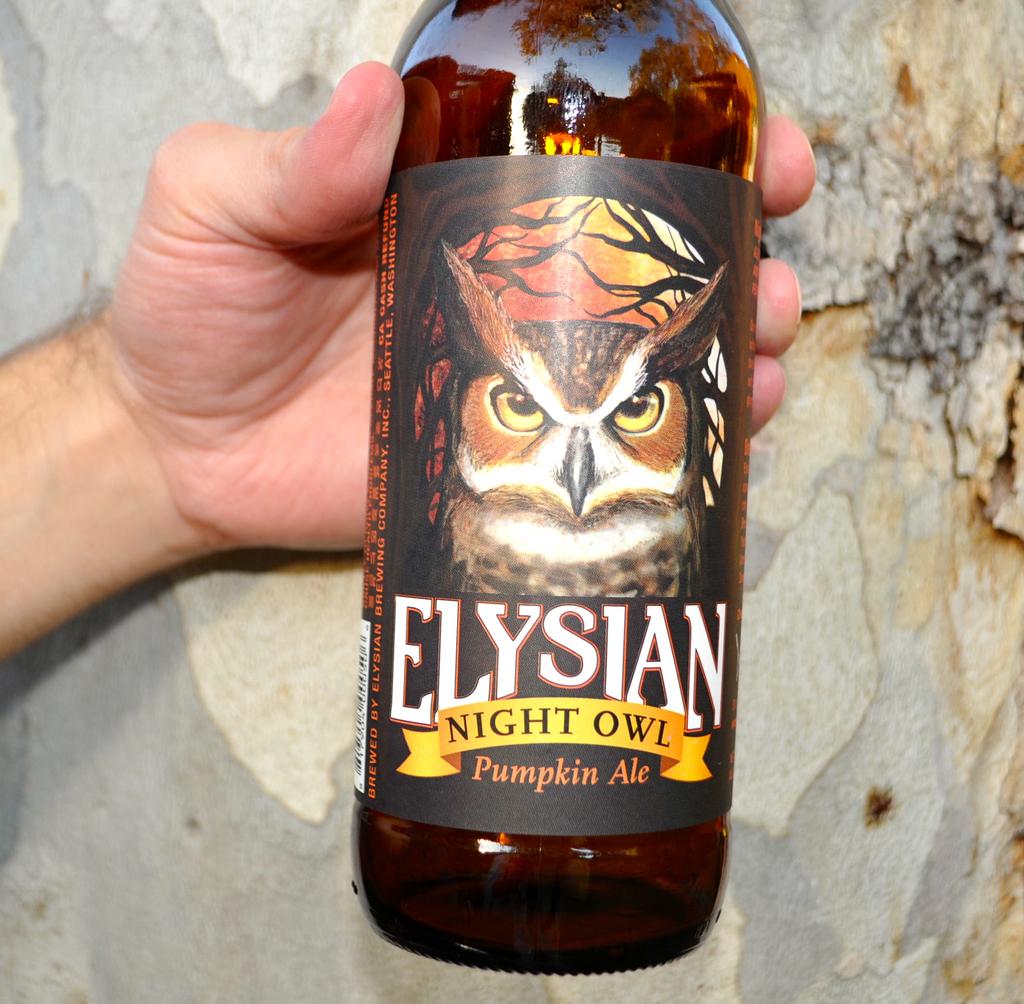What is the flavor of the ale?
Offer a terse response. Pumpkin. 